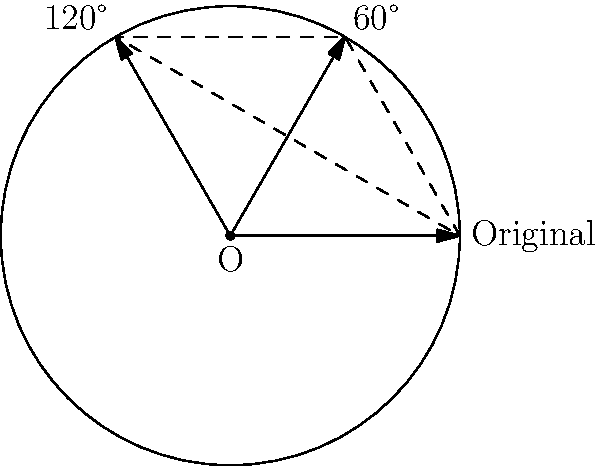A circular wildlife preserve with radius 3 km is being redesigned to maximize animal habitats. The preserve is divided into three equal sectors, each representing a different habitat. If the preserve is rotated 60° clockwise, what is the area of the region that remains in its original habitat after the rotation? To solve this problem, we need to follow these steps:

1) First, we need to understand that the total area of the circular preserve is divided into three equal sectors, each covering 120°.

2) When the preserve is rotated 60° clockwise, two-thirds of each sector will move into a new habitat, while one-third will remain in its original habitat.

3) The area of the entire circular preserve is:
   $A = \pi r^2 = \pi (3 \text{ km})^2 = 9\pi \text{ km}^2$

4) Since each sector represents one-third of the total area, the area of one sector is:
   $A_{sector} = \frac{1}{3} \cdot 9\pi \text{ km}^2 = 3\pi \text{ km}^2$

5) After rotation, only one-third of each sector remains in its original habitat. This is equivalent to one-third of the total area of the preserve:
   $A_{remaining} = \frac{1}{3} \cdot 9\pi \text{ km}^2 = 3\pi \text{ km}^2$

Therefore, the area that remains in its original habitat after rotation is $3\pi \text{ km}^2$.
Answer: $3\pi \text{ km}^2$ 